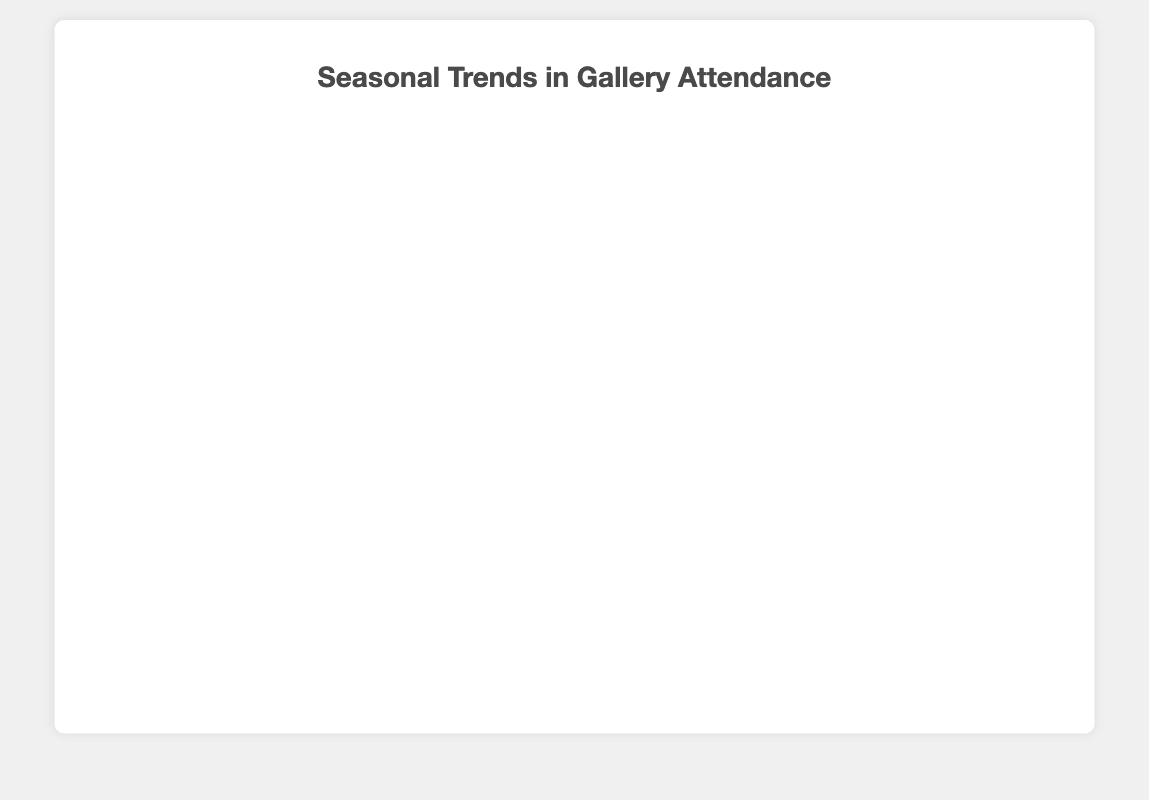How many events occurred in the Summer season? Identify which events are in the Summer season by looking at the color-coded data points and corresponding dates. Laguna Art Festival (July 10) and Laguna Niguel Summer Concert (August 15) occurred in Summer. Therefore, there are two events.
Answer: 2 Which event had the highest attendance? To find this, look at the y-axis, which represents attendance, and identify the highest data point. The Laguna Art Festival with an attendance of 150 has the highest attendance.
Answer: Laguna Art Festival What is the bubble size for the March Madness Art Show? Locate the point labeled March Madness Art Show and check its bubble size. The bubble size for the March Madness Art Show is 12.
Answer: 12 Which event had the lowest attendance and what was the weather like on that day? Find the lowest point on the y-axis and check the label. The First Thursday Art Walk with attendance of 45 had the lowest attendance, and it was rainy on that day.
Answer: First Thursday Art Walk, Rainy Compare the attendance for events that occurred in Spring. Identify the events that occurred in Spring, which are March Madness Art Show (75) and Earth Day Exhibition (130). Therefore, Earth Day Exhibition had higher attendance than March Madness Art Show.
Answer: Earth Day Exhibition had higher attendance What is the average bubble size for events with Sunny weather? Find events with Sunny weather: Laguna Art Festival (20), Laguna Niguel Summer Concert (18), and Earth Day Exhibition (19). Calculate the average: (20 + 18 + 19) / 3 = 57 / 3 = 19.
Answer: 19 Which events experienced similar weather conditions and had the closest attendance figures? Identify events with similar weather and compare attendance. Laguna Niguel Summer Concert (120) and Earth Day Exhibition (130), both Sunny, had close attendance figures. The difference is only 10.
Answer: Laguna Niguel Summer Concert and Earth Day Exhibition In which season did the gallery have the highest cumulative attendance? Sum the attendance per season: Spring (75 + 130 = 205), Summer (150 + 120 = 270), Fall (45), Winter (90). Summer has the highest cumulative attendance.
Answer: Summer Does the weather pattern seem to influence attendance? To answer, compare attendance figures with different weather. Sunny days (highest attendances: 150, 130, 120) generally have higher attendance compared to Cloudy (90) and Rainy (45). This suggests a positive influence of sunny weather on attendance.
Answer: Yes 